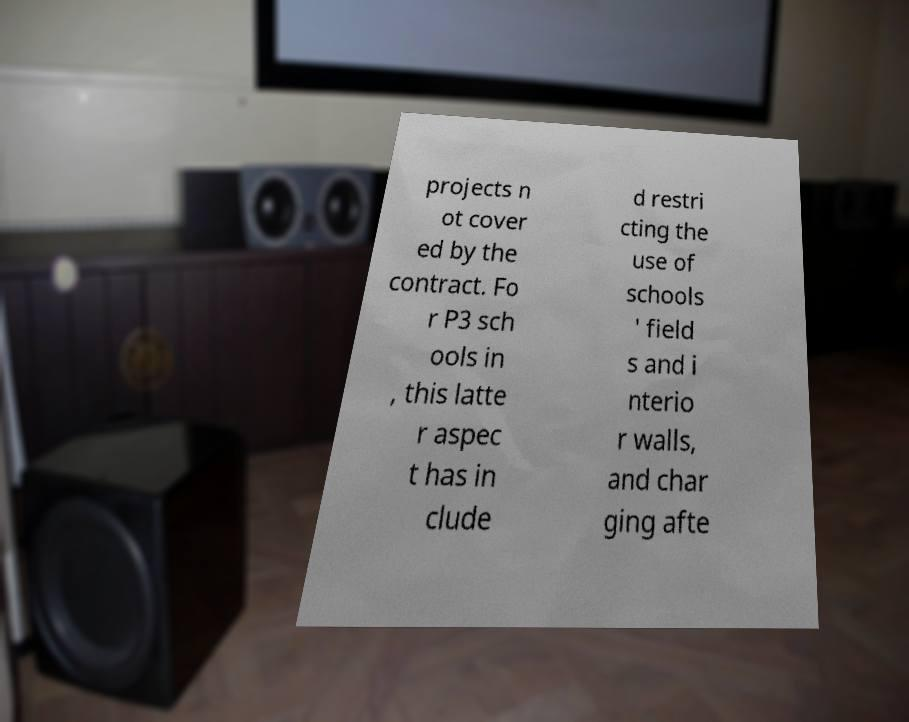Please identify and transcribe the text found in this image. projects n ot cover ed by the contract. Fo r P3 sch ools in , this latte r aspec t has in clude d restri cting the use of schools ' field s and i nterio r walls, and char ging afte 